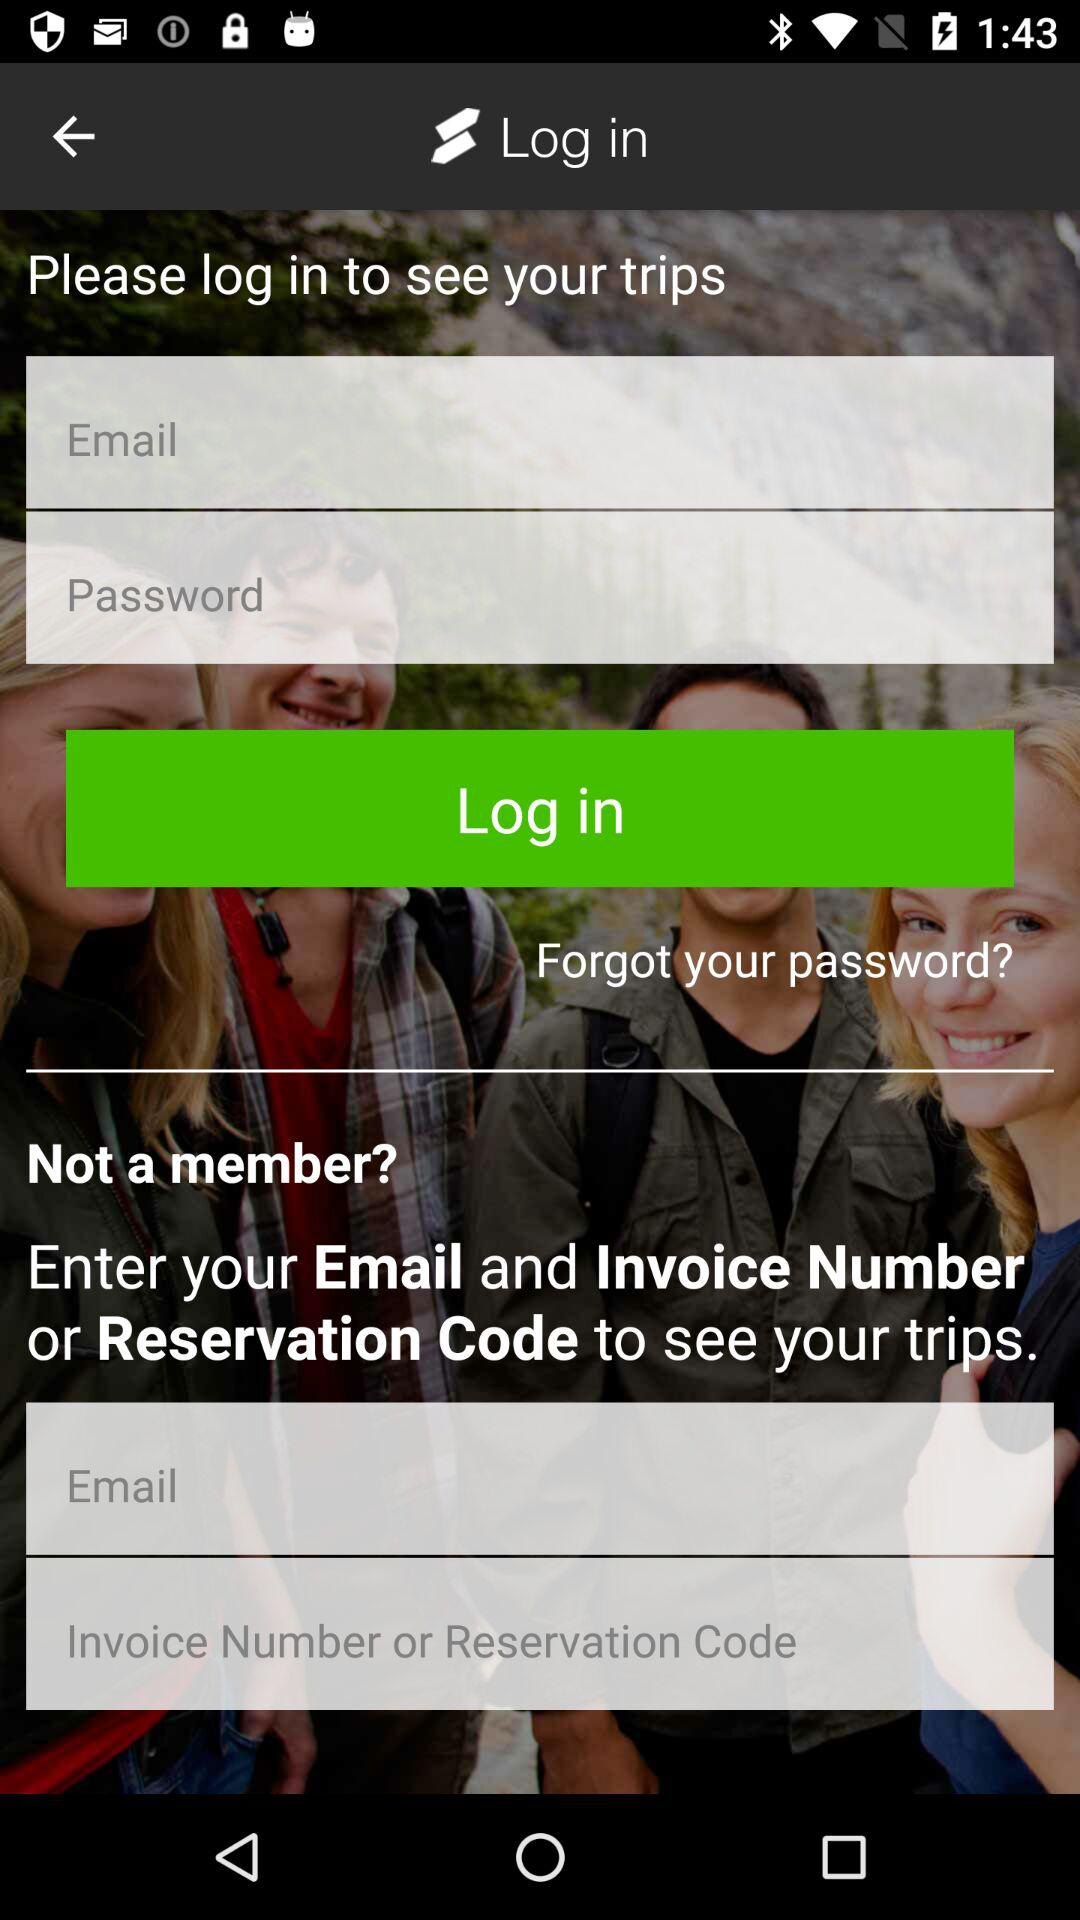How many text inputs are there for logging in?
Answer the question using a single word or phrase. 2 